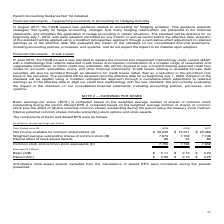According to Microsoft Corporation's financial document, How is basic earnings per share computed? Basic earnings per share (“EPS”) is computed based on the weighted average number of shares of common stock outstanding during the period.. The document states: "Basic earnings per share (“EPS”) is computed based on the weighted average number of shares of common stock outstanding during the period. Diluted EPS..." Also, How is diluted earnings per share computed? Diluted EPS is computed based on the weighted average number of shares of common stock plus the effect of dilutive potential common shares outstanding during the period using the treasury stock method.. The document states: "res of common stock outstanding during the period. Diluted EPS is computed based on the weighted average number of shares of common stock plus the eff..." Also, How much was the net income available for common shareholders in 2019? According to the financial document, 39,240 (in millions). The relevant text states: "et income available for common shareholders (A) $ 39,240 $ 16,571 $ 25,489..." Also, can you calculate: What was the average basic earnings per share over the 3 year period from 2017 to 2019? To answer this question, I need to perform calculations using the financial data. The calculation is: (5.11+2.15+3.29)/3 , which equals 3.52. This is based on the information: "Basic (A/B) $ 5.11 $ 2.15 $ 3.29 Basic (A/B) $ 5.11 $ 2.15 $ 3.29 Basic (A/B) $ 5.11 $ 2.15 $ 3.29..." The key data points involved are: 2.15, 3.29, 5.11. Also, can you calculate: What was the % change in net income available for common shareholders from 2018 to 2019? To answer this question, I need to perform calculations using the financial data. The calculation is: (39,240-16,571)/16,571, which equals 136.8 (percentage). This is based on the information: "available for common shareholders (A) $ 39,240 $ 16,571 $ 25,489 et income available for common shareholders (A) $ 39,240 $ 16,571 $ 25,489..." The key data points involved are: 16,571, 39,240. Also, can you calculate: What was the % change in the common stock and stock equivalents from 2018 to 2019? To answer this question, I need to perform calculations using the financial data. The calculation is: (7,753-7,794)/7,794, which equals -0.53 (percentage). This is based on the information: "Common stock and common stock equivalents (C) 7,753 7,794 7,832 mmon stock and common stock equivalents (C) 7,753 7,794 7,832..." The key data points involved are: 7,753, 7,794. 